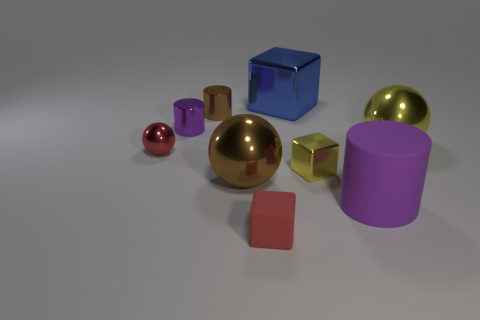Subtract all tiny red metal spheres. How many spheres are left? 2 Subtract all purple cylinders. How many cylinders are left? 1 Subtract all spheres. How many objects are left? 6 Subtract all purple blocks. Subtract all cyan spheres. How many blocks are left? 3 Subtract all gray cylinders. How many purple spheres are left? 0 Subtract all tiny cylinders. Subtract all small metal objects. How many objects are left? 3 Add 3 tiny metallic cylinders. How many tiny metallic cylinders are left? 5 Add 3 rubber blocks. How many rubber blocks exist? 4 Subtract 1 yellow balls. How many objects are left? 8 Subtract 2 spheres. How many spheres are left? 1 